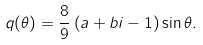<formula> <loc_0><loc_0><loc_500><loc_500>q ( \theta ) = \frac { 8 } { 9 } \left ( a + b i - 1 \right ) \sin \theta .</formula> 